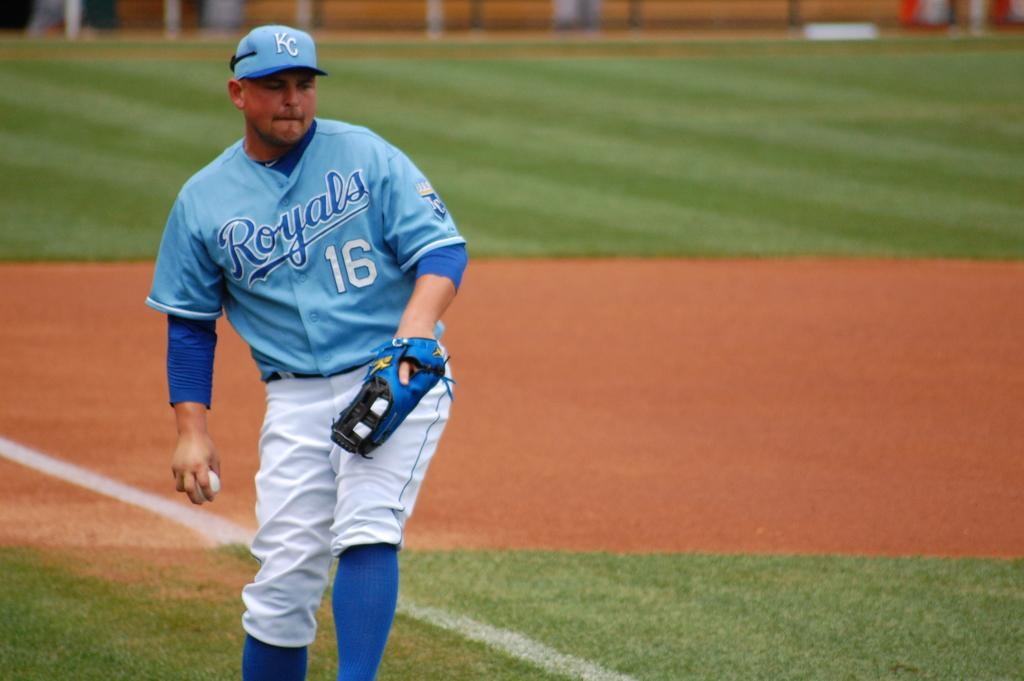<image>
Provide a brief description of the given image. a player with the number 16 on their jersey 